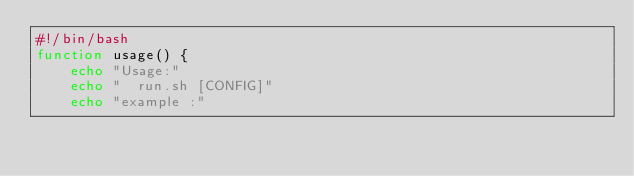Convert code to text. <code><loc_0><loc_0><loc_500><loc_500><_Bash_>#!/bin/bash
function usage() {
    echo "Usage:"
    echo "  run.sh [CONFIG]"
    echo "example :"</code> 